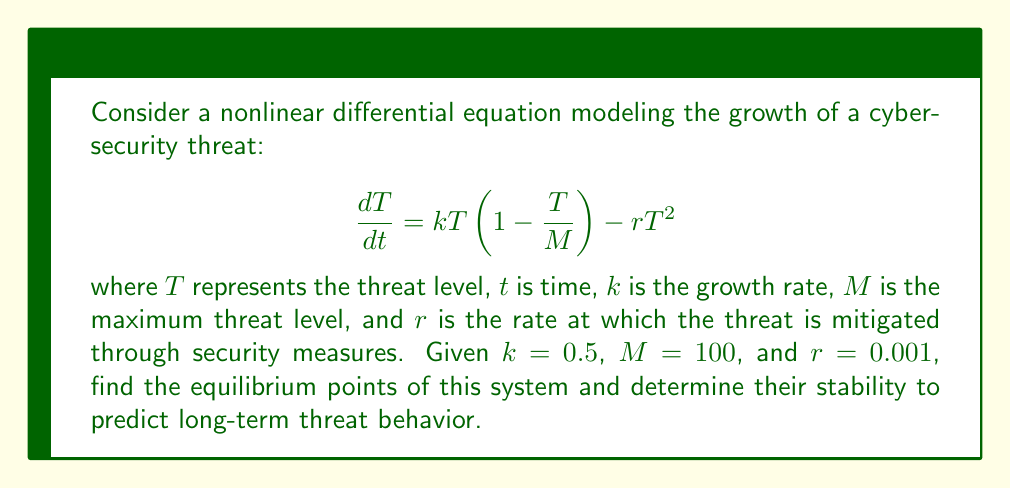Solve this math problem. To solve this problem, we'll follow these steps:

1) Find the equilibrium points by setting $\frac{dT}{dt} = 0$:

   $$0 = kT(1 - \frac{T}{M}) - rT^2$$
   $$0 = 0.5T(1 - \frac{T}{100}) - 0.001T^2$$

2) Simplify the equation:

   $$0 = 0.5T - 0.005T^2 - 0.001T^2$$
   $$0 = 0.5T - 0.006T^2$$
   $$0 = T(0.5 - 0.006T)$$

3) Solve for T:

   $T = 0$ or $0.5 - 0.006T = 0$
   
   For the second equation:
   $0.5 = 0.006T$
   $T = \frac{0.5}{0.006} \approx 83.33$

   So, the equilibrium points are $T_1 = 0$ and $T_2 \approx 83.33$.

4) Determine stability by evaluating $\frac{d}{dT}(\frac{dT}{dt})$ at each equilibrium point:

   $$\frac{d}{dT}(\frac{dT}{dt}) = k(1 - \frac{2T}{M}) - 2rT$$
   $$\frac{d}{dT}(\frac{dT}{dt}) = 0.5(1 - \frac{2T}{100}) - 0.002T$$

   At $T_1 = 0$:
   $\frac{d}{dT}(\frac{dT}{dt}) = 0.5 > 0$, so $T_1$ is unstable.

   At $T_2 \approx 83.33$:
   $\frac{d}{dT}(\frac{dT}{dt}) \approx 0.5(1 - \frac{2(83.33)}{100}) - 0.002(83.33) \approx -0.5 < 0$, so $T_2$ is stable.

5) Interpret the results: The system has two equilibrium points. The zero threat level ($T_1 = 0$) is unstable, meaning any small threat will grow. The non-zero threat level ($T_2 \approx 83.33$) is stable, indicating that the threat will tend to settle at this level in the long term due to the balance between growth and mitigation.
Answer: Equilibrium points: $T_1 = 0$ (unstable), $T_2 \approx 83.33$ (stable). Long-term prediction: threat level tends to stabilize around 83.33. 